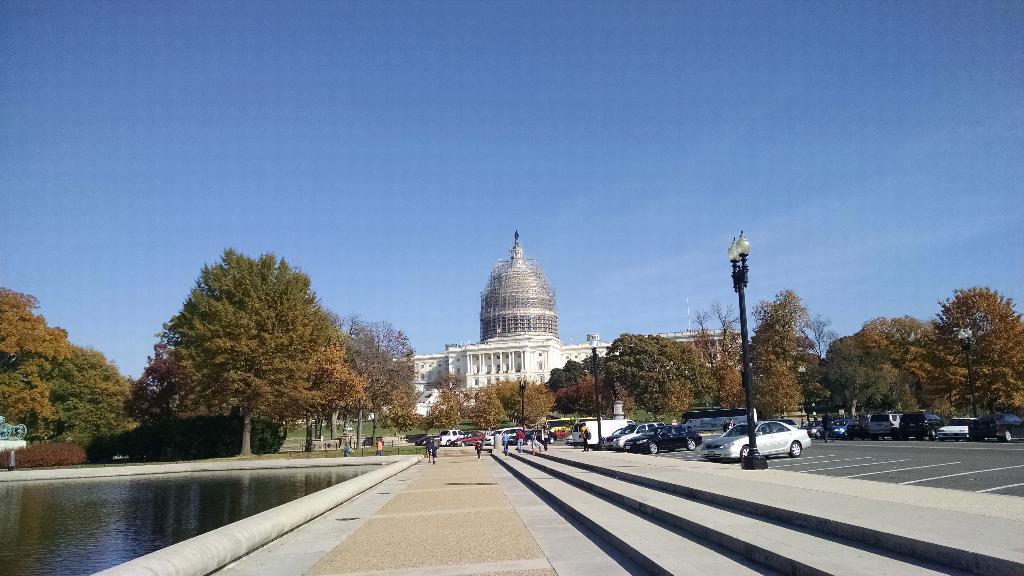Please provide a concise description of this image. On the left side, there is a water pond. In the middle, there is a road on which, there are persons. On the right side, there are steps and a light attached to the pole. In the background, there are vehicles on the road on which, there are white color lines, there are trees, a white color building and there are clouds in the blue sky. 